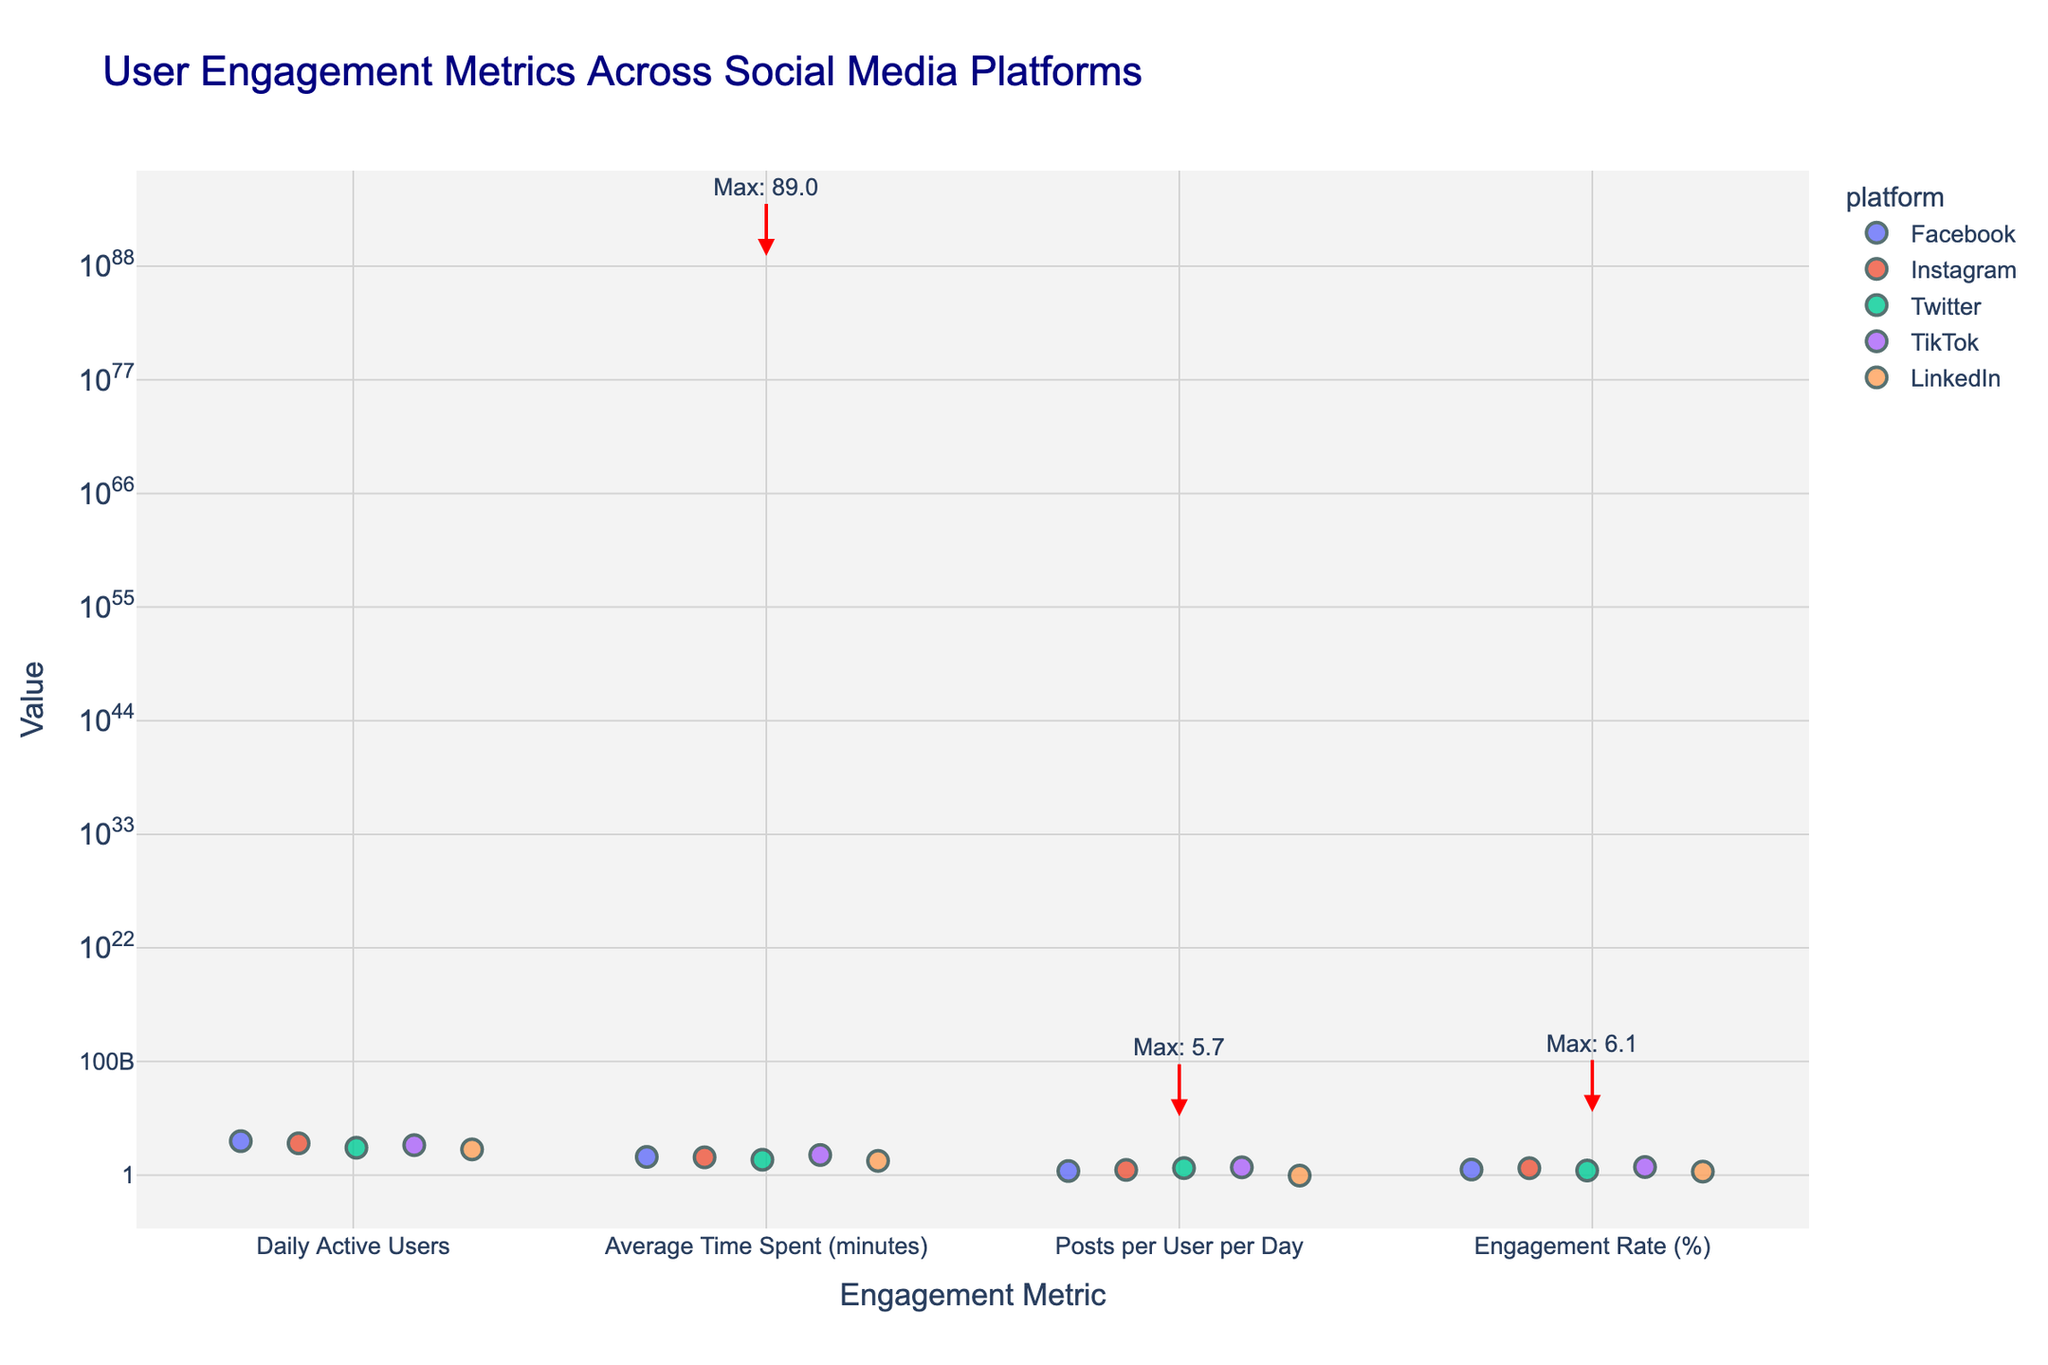What is the title of the figure? The title is written at the top center of the figure and describes the main subject of the plot.
Answer: User Engagement Metrics Across Social Media Platforms How many social media platforms are represented in the figure? To determine this, we count the unique entries in the legend or label that indicates different social media platforms.
Answer: 5 Which platform has the highest value for Daily Active Users? Look for the maximum value in the "Daily Active Users" strip and see which platform it is associated with.
Answer: Facebook What is the engagement rate for LinkedIn? Locate the point corresponding to LinkedIn on the "Engagement Rate (%)" strip and note the y-value.
Answer: 2.2% Which platform shows the greatest average time spent per user? Identify the tallest point on the "Average Time Spent (minutes)" strip and determine the associated platform.
Answer: TikTok Compare the average time spent on Facebook and Instagram. Which one is higher? Look at the positions of Facebook and Instagram on the "Average Time Spent (minutes)" strip and compare their values.
Answer: Facebook By how much does TikTok's engagement rate exceed Twitter's? First, find TikTok's and Twitter's engagement rate values and then compute the difference. TikTok: 6.1%, Twitter: 2.8%.
Answer: 3.3% What is the average number of posts per user per day across all platforms? Sum the number of posts per user per day for all platforms and divide by the number of platforms. (2.5 + 3.2 + 4.8 + 5.7 + 0.9) / 5 = 17.1 / 5 = 3.42
Answer: 3.42 Which engagement metric has the highest value overall, and what is that value? Find the highest point across all engagement metrics and read the value and associated metric. The engagement metric with the highest value is "Daily Active Users", where the maximum value is 1950 (Facebook).
Answer: Daily Active Users, 1950 What platform has the least number of daily active users? Look for the smallest value in the "Daily Active Users" strip and identify the associated platform.
Answer: LinkedIn 